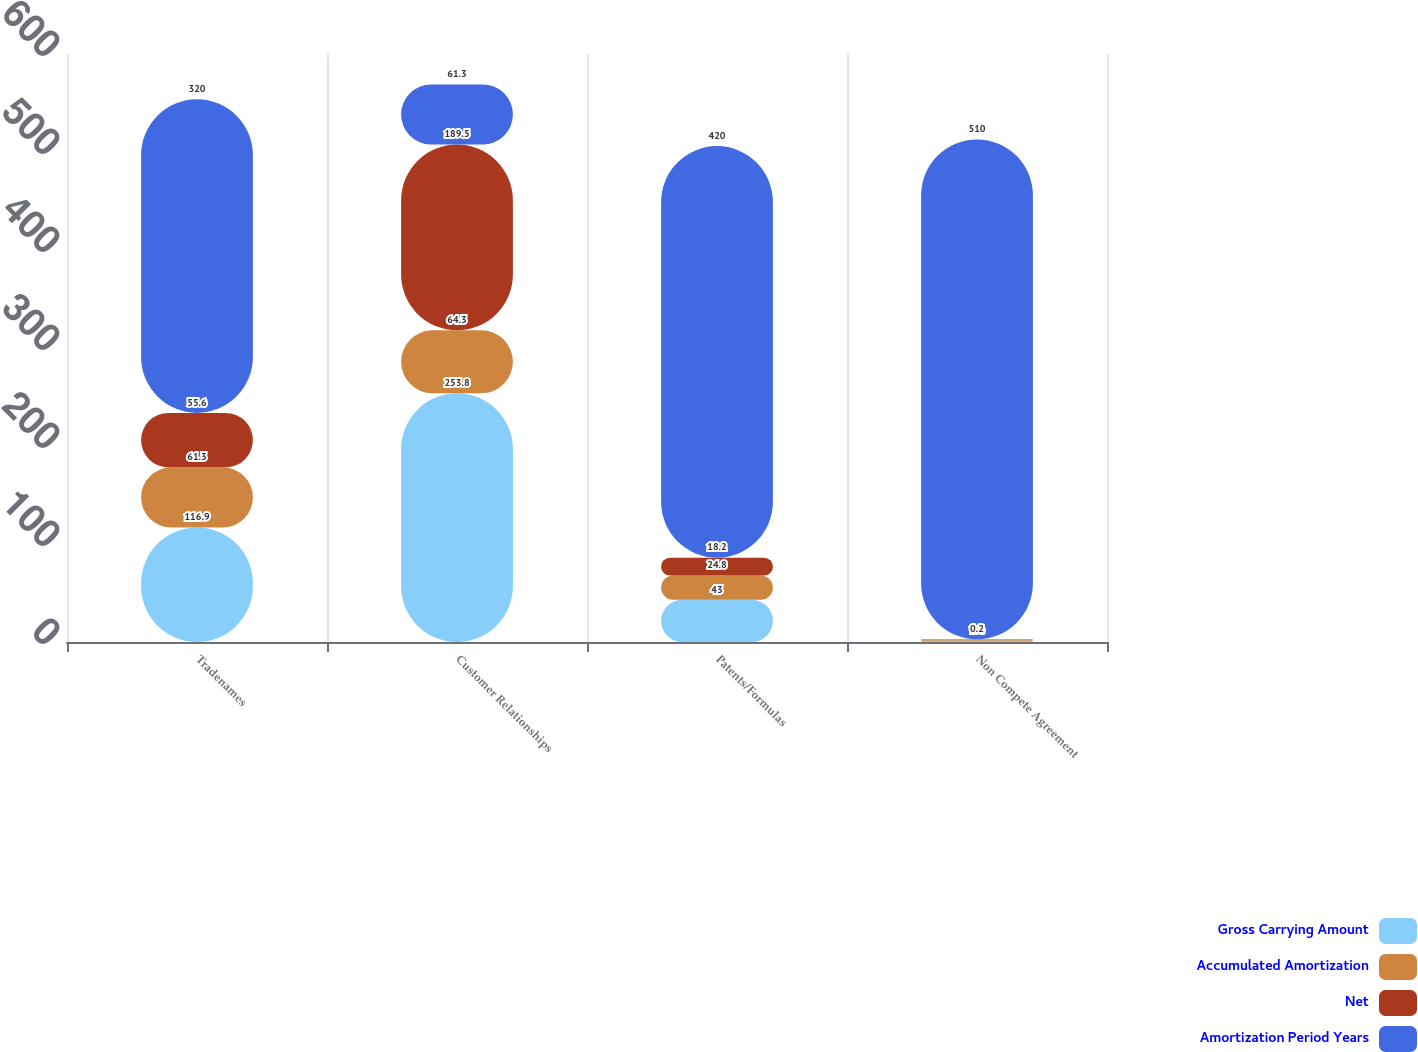<chart> <loc_0><loc_0><loc_500><loc_500><stacked_bar_chart><ecel><fcel>Tradenames<fcel>Customer Relationships<fcel>Patents/Formulas<fcel>Non Compete Agreement<nl><fcel>Gross Carrying Amount<fcel>116.9<fcel>253.8<fcel>43<fcel>1.4<nl><fcel>Accumulated Amortization<fcel>61.3<fcel>64.3<fcel>24.8<fcel>1.2<nl><fcel>Net<fcel>55.6<fcel>189.5<fcel>18.2<fcel>0.2<nl><fcel>Amortization Period Years<fcel>320<fcel>61.3<fcel>420<fcel>510<nl></chart> 